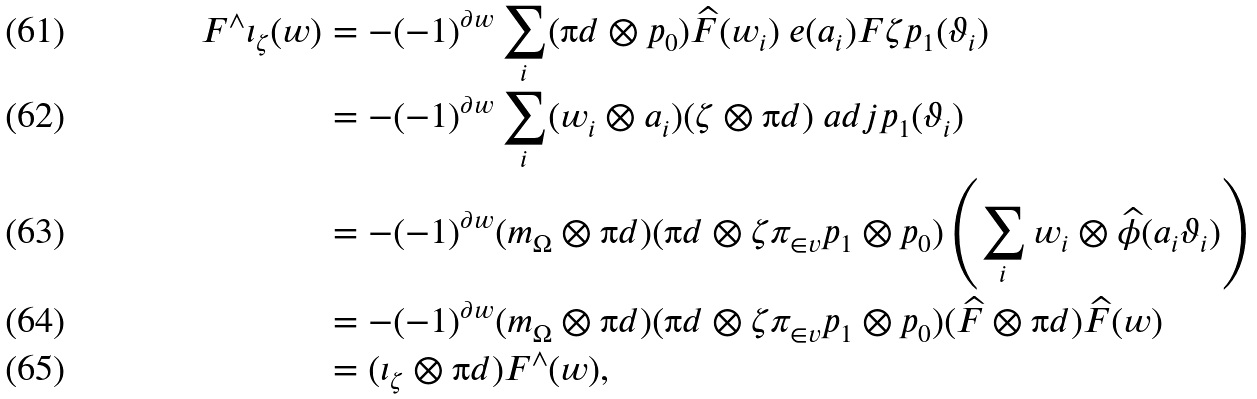<formula> <loc_0><loc_0><loc_500><loc_500>F ^ { \wedge } \iota _ { \zeta } ( w ) & = - ( - 1 ) ^ { \partial w } \sum _ { i } ( \i d \otimes p _ { 0 } ) \widehat { F } ( w _ { i } ) \ e ( a _ { i } ) F \zeta p _ { 1 } ( \vartheta _ { i } ) \\ & = - ( - 1 ) ^ { \partial w } \sum _ { i } ( w _ { i } \otimes a _ { i } ) ( \zeta \otimes \i d ) \ a d j p _ { 1 } ( \vartheta _ { i } ) \\ & = - ( - 1 ) ^ { \partial w } ( m _ { \Omega } \otimes \i d ) ( \i d \otimes \zeta \pi _ { \in v } p _ { 1 } \otimes p _ { 0 } ) \left ( \sum _ { i } w _ { i } \otimes \widehat { \phi } ( a _ { i } \vartheta _ { i } ) \right ) \\ & = - ( - 1 ) ^ { \partial w } ( m _ { \Omega } \otimes \i d ) ( \i d \otimes \zeta \pi _ { \in v } p _ { 1 } \otimes p _ { 0 } ) ( \widehat { F } \otimes \i d ) \widehat { F } ( w ) \\ & = ( \iota _ { \zeta } \otimes \i d ) F ^ { \wedge } ( w ) ,</formula> 